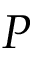Convert formula to latex. <formula><loc_0><loc_0><loc_500><loc_500>P</formula> 